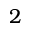Convert formula to latex. <formula><loc_0><loc_0><loc_500><loc_500>2</formula> 